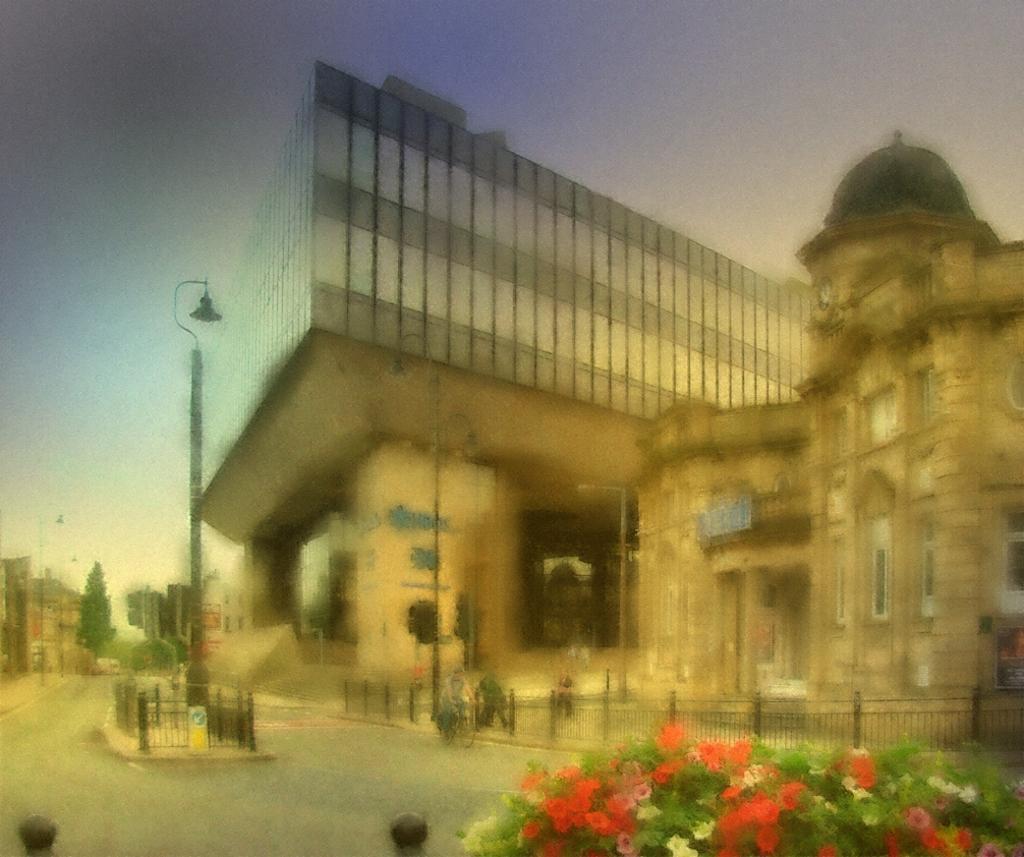How would you summarize this image in a sentence or two? In this image I can see at the bottom there are flower plants. In the middle there are buildings. At the top it is the sky. 